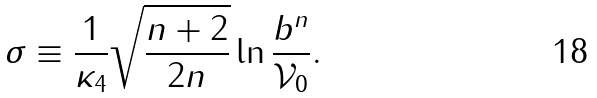Convert formula to latex. <formula><loc_0><loc_0><loc_500><loc_500>\sigma \equiv \frac { 1 } { \kappa _ { 4 } } \sqrt { \frac { n + 2 } { 2 n } } \ln \frac { b ^ { n } } { \mathcal { V } _ { 0 } } .</formula> 